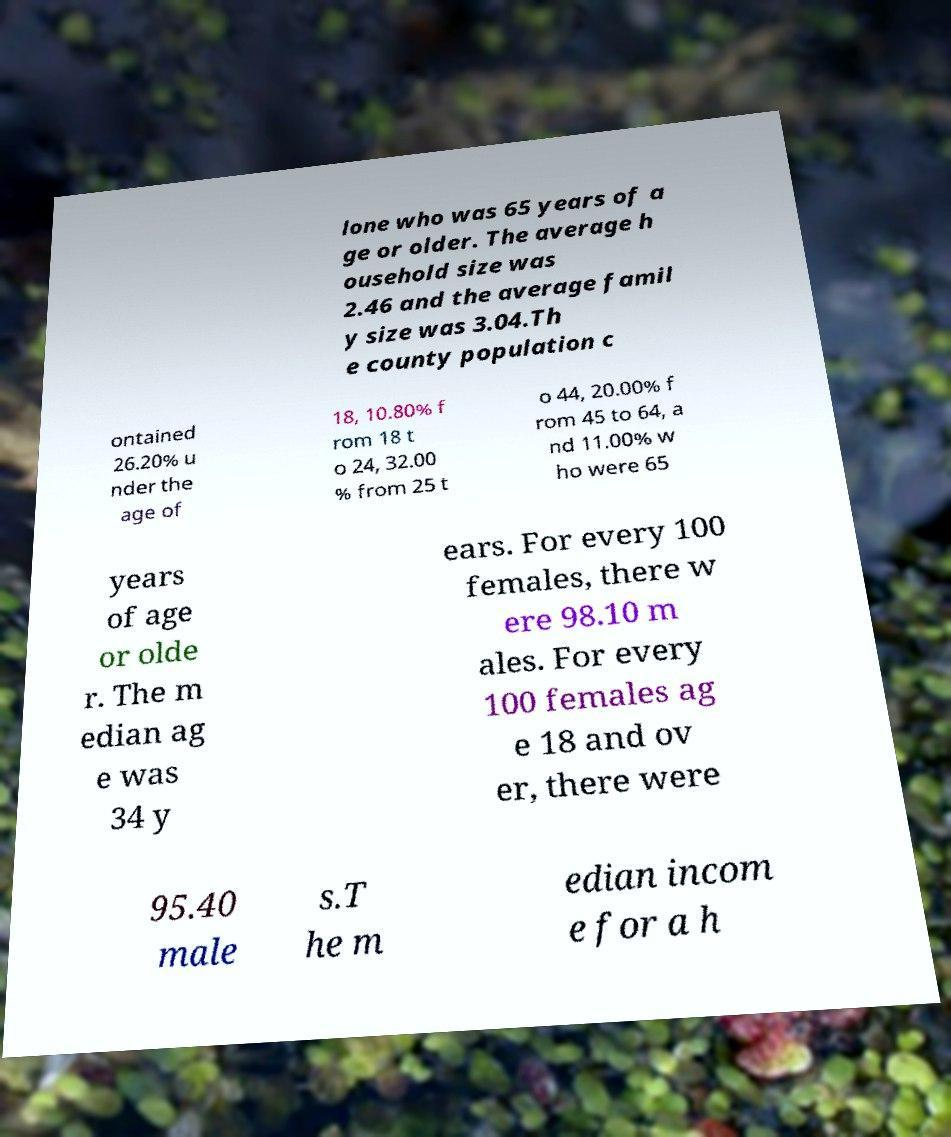Can you read and provide the text displayed in the image?This photo seems to have some interesting text. Can you extract and type it out for me? lone who was 65 years of a ge or older. The average h ousehold size was 2.46 and the average famil y size was 3.04.Th e county population c ontained 26.20% u nder the age of 18, 10.80% f rom 18 t o 24, 32.00 % from 25 t o 44, 20.00% f rom 45 to 64, a nd 11.00% w ho were 65 years of age or olde r. The m edian ag e was 34 y ears. For every 100 females, there w ere 98.10 m ales. For every 100 females ag e 18 and ov er, there were 95.40 male s.T he m edian incom e for a h 